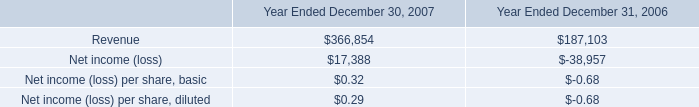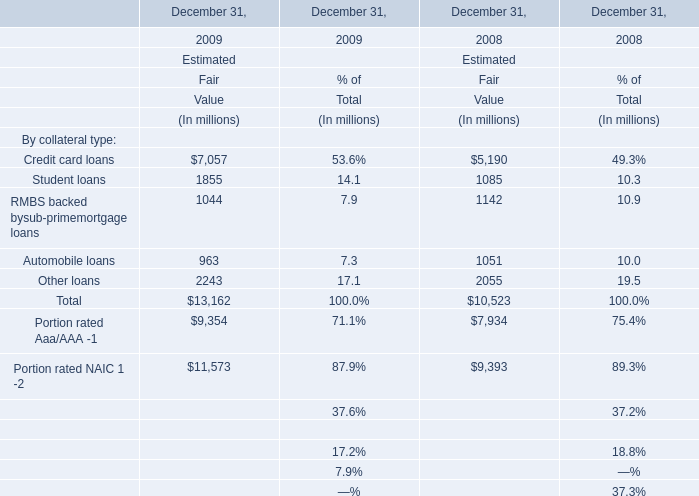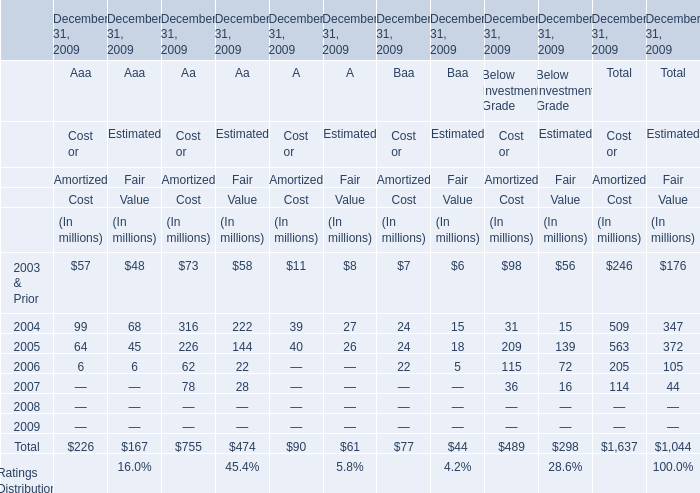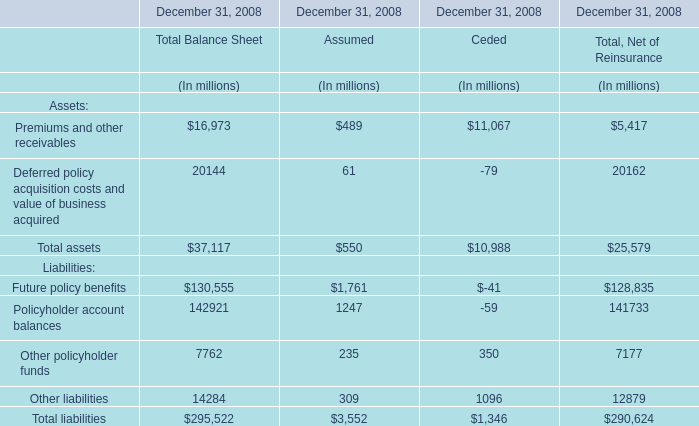From Grade Aaa, Aa,A,Baa, how many grades does Cost or Amortized Cost continues to increase every year from 2004 to 2006? 
Answer: 0. 